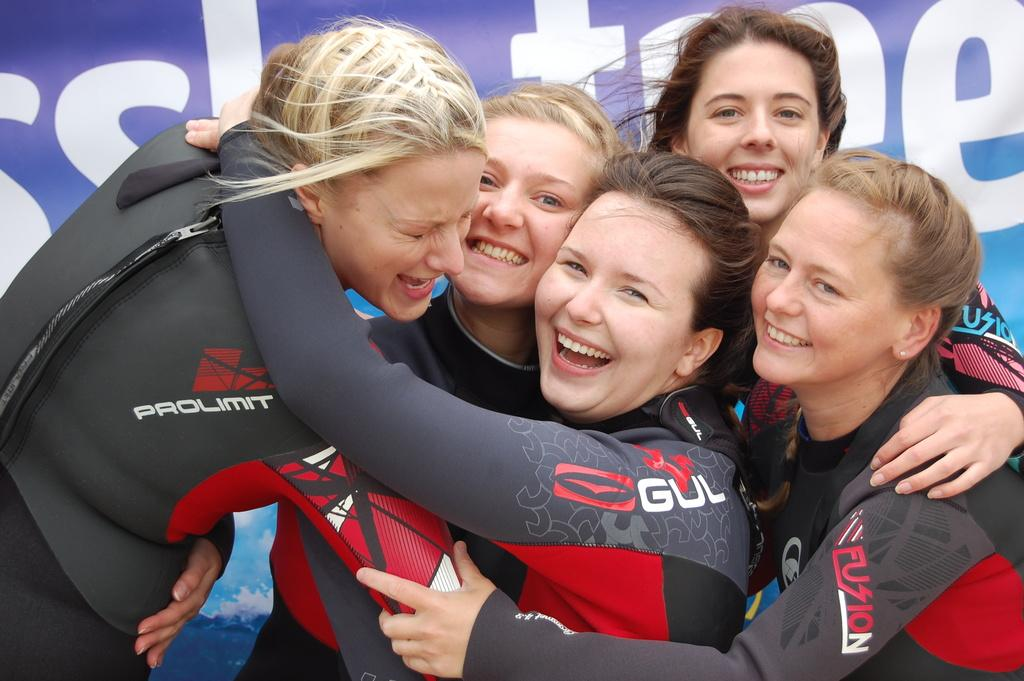What is happening in the center of the image? There are people in the center of the image. What is the facial expression of the people? The people are smiling. What are the people wearing? The people are wearing different costumes. What can be seen in the background of the image? There is a banner in the background of the image. What is written on the banner? The banner has text on it. Where is the pet located in the image? There is no pet present in the image. What type of mailbox can be seen near the people? There is no mailbox visible in the image. 